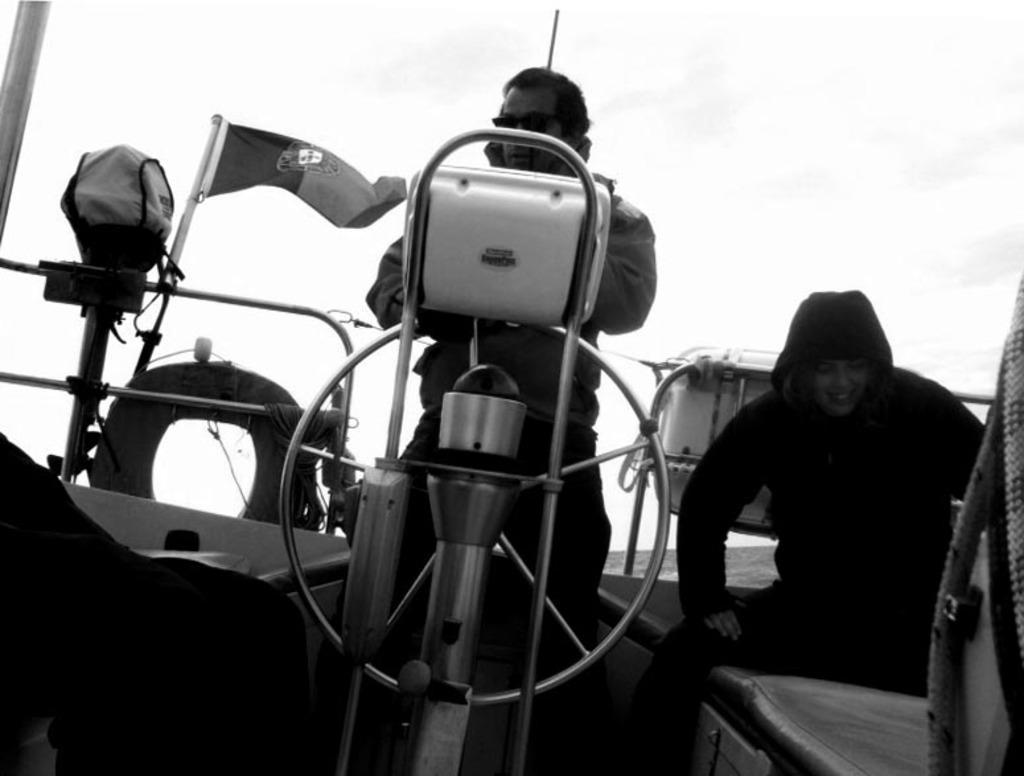Could you give a brief overview of what you see in this image? In this image there is a person standing in front of a steering wheel of a boat, beside the person there is a woman sitting, behind them there is a metal rod fence with flags, tubes and some other objects, around them there are some other objects and ropes, behind them there is water. 